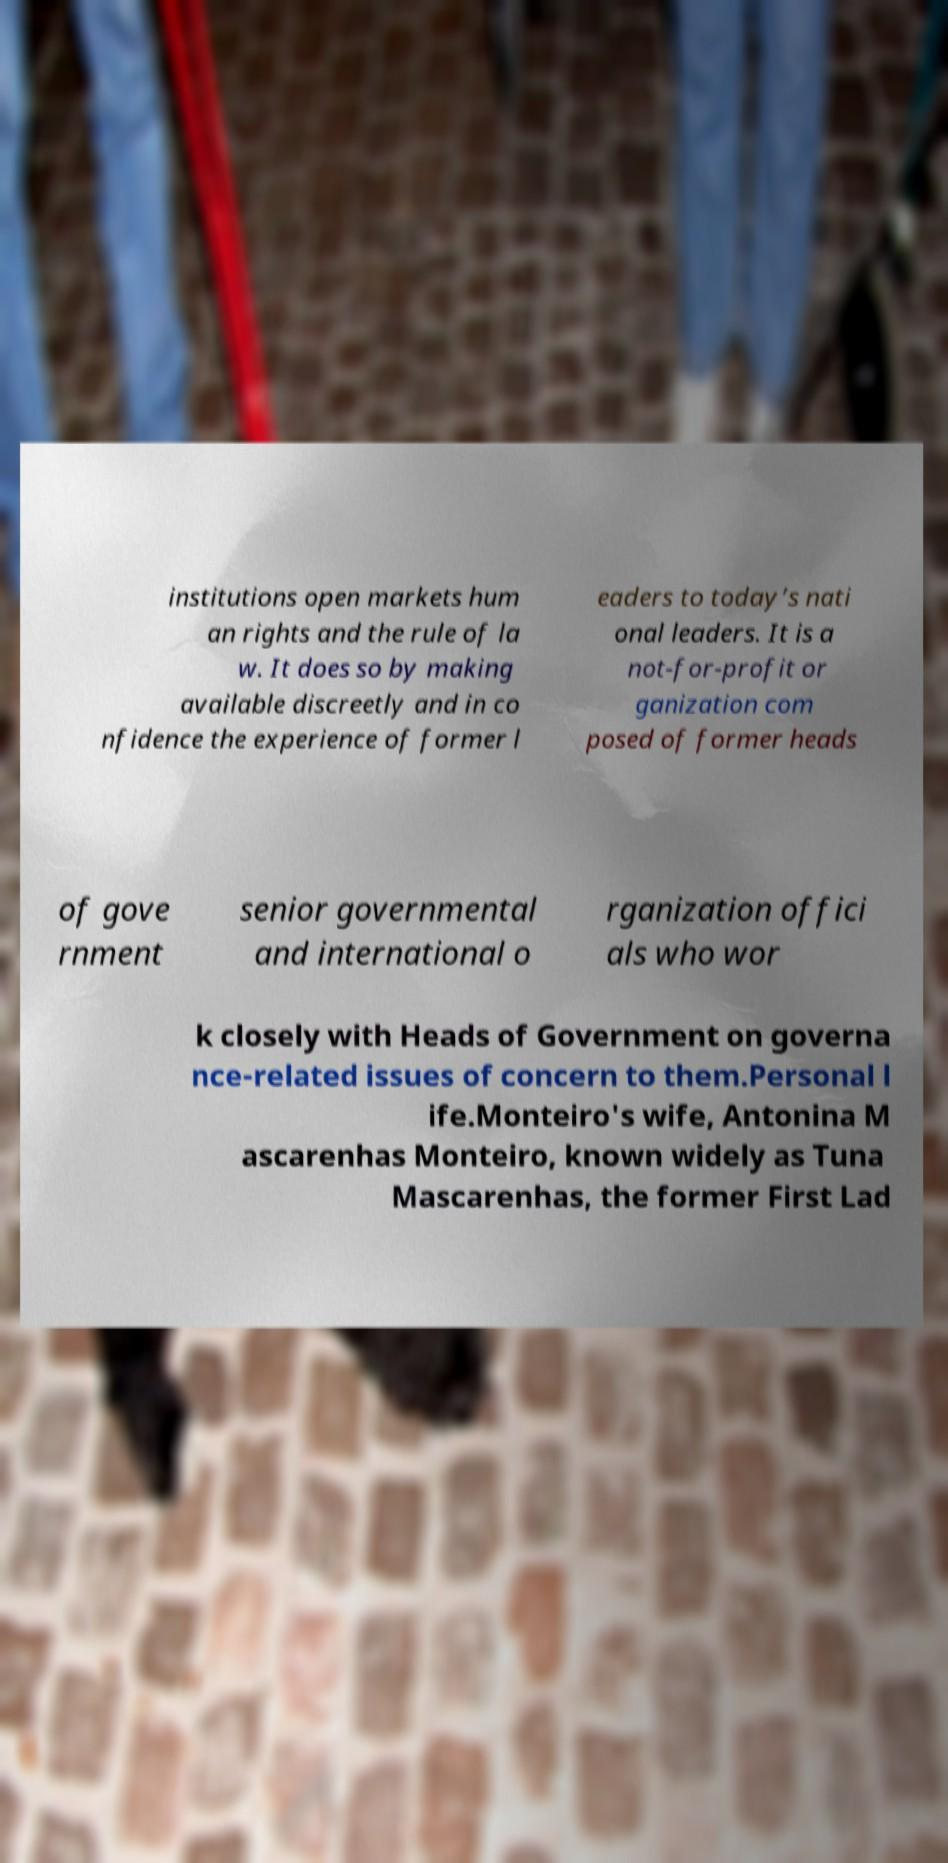Please identify and transcribe the text found in this image. institutions open markets hum an rights and the rule of la w. It does so by making available discreetly and in co nfidence the experience of former l eaders to today’s nati onal leaders. It is a not-for-profit or ganization com posed of former heads of gove rnment senior governmental and international o rganization offici als who wor k closely with Heads of Government on governa nce-related issues of concern to them.Personal l ife.Monteiro's wife, Antonina M ascarenhas Monteiro, known widely as Tuna Mascarenhas, the former First Lad 